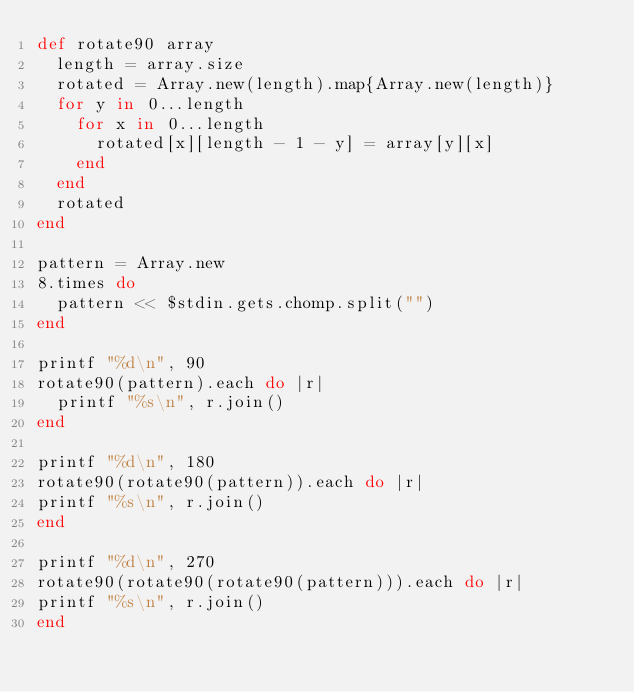<code> <loc_0><loc_0><loc_500><loc_500><_Ruby_>def rotate90 array
  length = array.size
  rotated = Array.new(length).map{Array.new(length)}
  for y in 0...length
    for x in 0...length
      rotated[x][length - 1 - y] = array[y][x]
    end
  end
  rotated
end

pattern = Array.new
8.times do
  pattern << $stdin.gets.chomp.split("")
end

printf "%d\n", 90
rotate90(pattern).each do |r|
  printf "%s\n", r.join()
end

printf "%d\n", 180
rotate90(rotate90(pattern)).each do |r|
printf "%s\n", r.join()
end

printf "%d\n", 270
rotate90(rotate90(rotate90(pattern))).each do |r|
printf "%s\n", r.join()
end</code> 